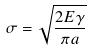Convert formula to latex. <formula><loc_0><loc_0><loc_500><loc_500>\sigma = \sqrt { \frac { 2 E \gamma } { \pi a } }</formula> 